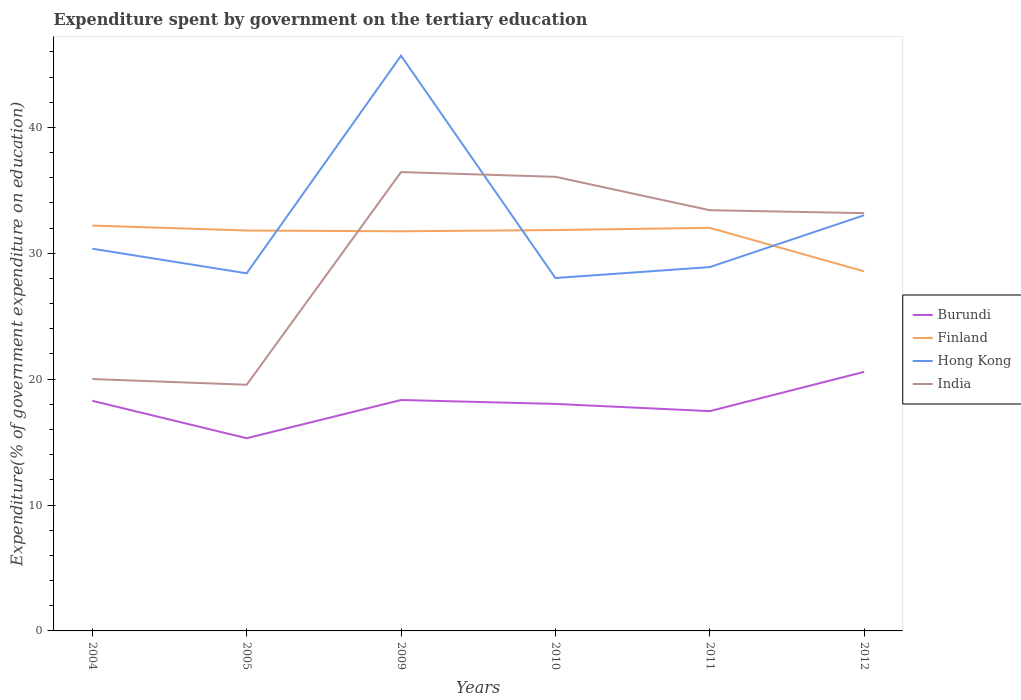Is the number of lines equal to the number of legend labels?
Provide a short and direct response. Yes. Across all years, what is the maximum expenditure spent by government on the tertiary education in Burundi?
Ensure brevity in your answer.  15.31. In which year was the expenditure spent by government on the tertiary education in Hong Kong maximum?
Make the answer very short. 2010. What is the total expenditure spent by government on the tertiary education in Finland in the graph?
Your answer should be very brief. 0.45. What is the difference between the highest and the second highest expenditure spent by government on the tertiary education in Burundi?
Offer a terse response. 5.27. Is the expenditure spent by government on the tertiary education in India strictly greater than the expenditure spent by government on the tertiary education in Finland over the years?
Provide a succinct answer. No. Are the values on the major ticks of Y-axis written in scientific E-notation?
Provide a succinct answer. No. Does the graph contain any zero values?
Keep it short and to the point. No. What is the title of the graph?
Give a very brief answer. Expenditure spent by government on the tertiary education. Does "Liechtenstein" appear as one of the legend labels in the graph?
Offer a terse response. No. What is the label or title of the X-axis?
Your response must be concise. Years. What is the label or title of the Y-axis?
Ensure brevity in your answer.  Expenditure(% of government expenditure on education). What is the Expenditure(% of government expenditure on education) in Burundi in 2004?
Offer a very short reply. 18.28. What is the Expenditure(% of government expenditure on education) of Finland in 2004?
Your response must be concise. 32.2. What is the Expenditure(% of government expenditure on education) in Hong Kong in 2004?
Ensure brevity in your answer.  30.36. What is the Expenditure(% of government expenditure on education) in India in 2004?
Your answer should be compact. 20.01. What is the Expenditure(% of government expenditure on education) of Burundi in 2005?
Provide a short and direct response. 15.31. What is the Expenditure(% of government expenditure on education) of Finland in 2005?
Offer a terse response. 31.81. What is the Expenditure(% of government expenditure on education) in Hong Kong in 2005?
Provide a short and direct response. 28.41. What is the Expenditure(% of government expenditure on education) of India in 2005?
Offer a very short reply. 19.55. What is the Expenditure(% of government expenditure on education) in Burundi in 2009?
Provide a short and direct response. 18.35. What is the Expenditure(% of government expenditure on education) in Finland in 2009?
Your answer should be very brief. 31.75. What is the Expenditure(% of government expenditure on education) of Hong Kong in 2009?
Keep it short and to the point. 45.7. What is the Expenditure(% of government expenditure on education) in India in 2009?
Give a very brief answer. 36.45. What is the Expenditure(% of government expenditure on education) of Burundi in 2010?
Make the answer very short. 18.03. What is the Expenditure(% of government expenditure on education) in Finland in 2010?
Give a very brief answer. 31.85. What is the Expenditure(% of government expenditure on education) of Hong Kong in 2010?
Keep it short and to the point. 28.04. What is the Expenditure(% of government expenditure on education) of India in 2010?
Your response must be concise. 36.08. What is the Expenditure(% of government expenditure on education) in Burundi in 2011?
Your answer should be very brief. 17.46. What is the Expenditure(% of government expenditure on education) in Finland in 2011?
Provide a short and direct response. 32.02. What is the Expenditure(% of government expenditure on education) in Hong Kong in 2011?
Give a very brief answer. 28.9. What is the Expenditure(% of government expenditure on education) of India in 2011?
Your answer should be very brief. 33.42. What is the Expenditure(% of government expenditure on education) of Burundi in 2012?
Provide a succinct answer. 20.58. What is the Expenditure(% of government expenditure on education) in Finland in 2012?
Your answer should be compact. 28.56. What is the Expenditure(% of government expenditure on education) of Hong Kong in 2012?
Your response must be concise. 33.02. What is the Expenditure(% of government expenditure on education) of India in 2012?
Offer a very short reply. 33.19. Across all years, what is the maximum Expenditure(% of government expenditure on education) in Burundi?
Your answer should be compact. 20.58. Across all years, what is the maximum Expenditure(% of government expenditure on education) of Finland?
Make the answer very short. 32.2. Across all years, what is the maximum Expenditure(% of government expenditure on education) in Hong Kong?
Provide a short and direct response. 45.7. Across all years, what is the maximum Expenditure(% of government expenditure on education) of India?
Keep it short and to the point. 36.45. Across all years, what is the minimum Expenditure(% of government expenditure on education) in Burundi?
Your answer should be very brief. 15.31. Across all years, what is the minimum Expenditure(% of government expenditure on education) in Finland?
Offer a very short reply. 28.56. Across all years, what is the minimum Expenditure(% of government expenditure on education) of Hong Kong?
Offer a very short reply. 28.04. Across all years, what is the minimum Expenditure(% of government expenditure on education) in India?
Offer a terse response. 19.55. What is the total Expenditure(% of government expenditure on education) in Burundi in the graph?
Offer a terse response. 108.01. What is the total Expenditure(% of government expenditure on education) of Finland in the graph?
Offer a terse response. 188.2. What is the total Expenditure(% of government expenditure on education) of Hong Kong in the graph?
Your answer should be very brief. 194.43. What is the total Expenditure(% of government expenditure on education) of India in the graph?
Your answer should be very brief. 178.71. What is the difference between the Expenditure(% of government expenditure on education) in Burundi in 2004 and that in 2005?
Provide a short and direct response. 2.98. What is the difference between the Expenditure(% of government expenditure on education) of Finland in 2004 and that in 2005?
Offer a terse response. 0.39. What is the difference between the Expenditure(% of government expenditure on education) in Hong Kong in 2004 and that in 2005?
Your response must be concise. 1.95. What is the difference between the Expenditure(% of government expenditure on education) in India in 2004 and that in 2005?
Your answer should be compact. 0.46. What is the difference between the Expenditure(% of government expenditure on education) of Burundi in 2004 and that in 2009?
Provide a succinct answer. -0.06. What is the difference between the Expenditure(% of government expenditure on education) of Finland in 2004 and that in 2009?
Keep it short and to the point. 0.45. What is the difference between the Expenditure(% of government expenditure on education) of Hong Kong in 2004 and that in 2009?
Offer a very short reply. -15.33. What is the difference between the Expenditure(% of government expenditure on education) in India in 2004 and that in 2009?
Make the answer very short. -16.44. What is the difference between the Expenditure(% of government expenditure on education) of Burundi in 2004 and that in 2010?
Provide a short and direct response. 0.25. What is the difference between the Expenditure(% of government expenditure on education) in Finland in 2004 and that in 2010?
Provide a succinct answer. 0.35. What is the difference between the Expenditure(% of government expenditure on education) of Hong Kong in 2004 and that in 2010?
Make the answer very short. 2.33. What is the difference between the Expenditure(% of government expenditure on education) of India in 2004 and that in 2010?
Your answer should be very brief. -16.06. What is the difference between the Expenditure(% of government expenditure on education) of Burundi in 2004 and that in 2011?
Ensure brevity in your answer.  0.82. What is the difference between the Expenditure(% of government expenditure on education) of Finland in 2004 and that in 2011?
Give a very brief answer. 0.18. What is the difference between the Expenditure(% of government expenditure on education) in Hong Kong in 2004 and that in 2011?
Provide a short and direct response. 1.46. What is the difference between the Expenditure(% of government expenditure on education) of India in 2004 and that in 2011?
Provide a short and direct response. -13.41. What is the difference between the Expenditure(% of government expenditure on education) in Burundi in 2004 and that in 2012?
Provide a succinct answer. -2.3. What is the difference between the Expenditure(% of government expenditure on education) in Finland in 2004 and that in 2012?
Give a very brief answer. 3.64. What is the difference between the Expenditure(% of government expenditure on education) in Hong Kong in 2004 and that in 2012?
Keep it short and to the point. -2.66. What is the difference between the Expenditure(% of government expenditure on education) of India in 2004 and that in 2012?
Ensure brevity in your answer.  -13.18. What is the difference between the Expenditure(% of government expenditure on education) in Burundi in 2005 and that in 2009?
Ensure brevity in your answer.  -3.04. What is the difference between the Expenditure(% of government expenditure on education) of Finland in 2005 and that in 2009?
Keep it short and to the point. 0.06. What is the difference between the Expenditure(% of government expenditure on education) of Hong Kong in 2005 and that in 2009?
Give a very brief answer. -17.29. What is the difference between the Expenditure(% of government expenditure on education) of India in 2005 and that in 2009?
Ensure brevity in your answer.  -16.9. What is the difference between the Expenditure(% of government expenditure on education) in Burundi in 2005 and that in 2010?
Ensure brevity in your answer.  -2.73. What is the difference between the Expenditure(% of government expenditure on education) of Finland in 2005 and that in 2010?
Offer a terse response. -0.04. What is the difference between the Expenditure(% of government expenditure on education) in Hong Kong in 2005 and that in 2010?
Provide a short and direct response. 0.37. What is the difference between the Expenditure(% of government expenditure on education) of India in 2005 and that in 2010?
Make the answer very short. -16.52. What is the difference between the Expenditure(% of government expenditure on education) of Burundi in 2005 and that in 2011?
Offer a terse response. -2.15. What is the difference between the Expenditure(% of government expenditure on education) in Finland in 2005 and that in 2011?
Give a very brief answer. -0.21. What is the difference between the Expenditure(% of government expenditure on education) of Hong Kong in 2005 and that in 2011?
Ensure brevity in your answer.  -0.49. What is the difference between the Expenditure(% of government expenditure on education) of India in 2005 and that in 2011?
Offer a very short reply. -13.87. What is the difference between the Expenditure(% of government expenditure on education) of Burundi in 2005 and that in 2012?
Ensure brevity in your answer.  -5.27. What is the difference between the Expenditure(% of government expenditure on education) of Finland in 2005 and that in 2012?
Provide a succinct answer. 3.25. What is the difference between the Expenditure(% of government expenditure on education) of Hong Kong in 2005 and that in 2012?
Ensure brevity in your answer.  -4.61. What is the difference between the Expenditure(% of government expenditure on education) in India in 2005 and that in 2012?
Provide a succinct answer. -13.63. What is the difference between the Expenditure(% of government expenditure on education) in Burundi in 2009 and that in 2010?
Your answer should be compact. 0.31. What is the difference between the Expenditure(% of government expenditure on education) of Finland in 2009 and that in 2010?
Your answer should be compact. -0.1. What is the difference between the Expenditure(% of government expenditure on education) of Hong Kong in 2009 and that in 2010?
Your response must be concise. 17.66. What is the difference between the Expenditure(% of government expenditure on education) of India in 2009 and that in 2010?
Your response must be concise. 0.37. What is the difference between the Expenditure(% of government expenditure on education) of Burundi in 2009 and that in 2011?
Give a very brief answer. 0.89. What is the difference between the Expenditure(% of government expenditure on education) of Finland in 2009 and that in 2011?
Offer a terse response. -0.27. What is the difference between the Expenditure(% of government expenditure on education) in Hong Kong in 2009 and that in 2011?
Offer a very short reply. 16.79. What is the difference between the Expenditure(% of government expenditure on education) in India in 2009 and that in 2011?
Make the answer very short. 3.03. What is the difference between the Expenditure(% of government expenditure on education) of Burundi in 2009 and that in 2012?
Your response must be concise. -2.23. What is the difference between the Expenditure(% of government expenditure on education) of Finland in 2009 and that in 2012?
Offer a terse response. 3.18. What is the difference between the Expenditure(% of government expenditure on education) in Hong Kong in 2009 and that in 2012?
Give a very brief answer. 12.67. What is the difference between the Expenditure(% of government expenditure on education) of India in 2009 and that in 2012?
Give a very brief answer. 3.26. What is the difference between the Expenditure(% of government expenditure on education) in Burundi in 2010 and that in 2011?
Provide a short and direct response. 0.57. What is the difference between the Expenditure(% of government expenditure on education) of Finland in 2010 and that in 2011?
Keep it short and to the point. -0.18. What is the difference between the Expenditure(% of government expenditure on education) in Hong Kong in 2010 and that in 2011?
Give a very brief answer. -0.87. What is the difference between the Expenditure(% of government expenditure on education) in India in 2010 and that in 2011?
Provide a short and direct response. 2.65. What is the difference between the Expenditure(% of government expenditure on education) in Burundi in 2010 and that in 2012?
Your answer should be compact. -2.55. What is the difference between the Expenditure(% of government expenditure on education) of Finland in 2010 and that in 2012?
Ensure brevity in your answer.  3.28. What is the difference between the Expenditure(% of government expenditure on education) in Hong Kong in 2010 and that in 2012?
Your answer should be very brief. -4.99. What is the difference between the Expenditure(% of government expenditure on education) of India in 2010 and that in 2012?
Offer a very short reply. 2.89. What is the difference between the Expenditure(% of government expenditure on education) in Burundi in 2011 and that in 2012?
Your answer should be very brief. -3.12. What is the difference between the Expenditure(% of government expenditure on education) in Finland in 2011 and that in 2012?
Offer a terse response. 3.46. What is the difference between the Expenditure(% of government expenditure on education) in Hong Kong in 2011 and that in 2012?
Make the answer very short. -4.12. What is the difference between the Expenditure(% of government expenditure on education) of India in 2011 and that in 2012?
Your response must be concise. 0.23. What is the difference between the Expenditure(% of government expenditure on education) in Burundi in 2004 and the Expenditure(% of government expenditure on education) in Finland in 2005?
Your response must be concise. -13.53. What is the difference between the Expenditure(% of government expenditure on education) of Burundi in 2004 and the Expenditure(% of government expenditure on education) of Hong Kong in 2005?
Your answer should be compact. -10.13. What is the difference between the Expenditure(% of government expenditure on education) of Burundi in 2004 and the Expenditure(% of government expenditure on education) of India in 2005?
Your response must be concise. -1.27. What is the difference between the Expenditure(% of government expenditure on education) in Finland in 2004 and the Expenditure(% of government expenditure on education) in Hong Kong in 2005?
Offer a very short reply. 3.79. What is the difference between the Expenditure(% of government expenditure on education) in Finland in 2004 and the Expenditure(% of government expenditure on education) in India in 2005?
Your answer should be compact. 12.65. What is the difference between the Expenditure(% of government expenditure on education) in Hong Kong in 2004 and the Expenditure(% of government expenditure on education) in India in 2005?
Ensure brevity in your answer.  10.81. What is the difference between the Expenditure(% of government expenditure on education) in Burundi in 2004 and the Expenditure(% of government expenditure on education) in Finland in 2009?
Provide a short and direct response. -13.47. What is the difference between the Expenditure(% of government expenditure on education) in Burundi in 2004 and the Expenditure(% of government expenditure on education) in Hong Kong in 2009?
Your response must be concise. -27.41. What is the difference between the Expenditure(% of government expenditure on education) in Burundi in 2004 and the Expenditure(% of government expenditure on education) in India in 2009?
Your answer should be compact. -18.17. What is the difference between the Expenditure(% of government expenditure on education) in Finland in 2004 and the Expenditure(% of government expenditure on education) in Hong Kong in 2009?
Keep it short and to the point. -13.5. What is the difference between the Expenditure(% of government expenditure on education) of Finland in 2004 and the Expenditure(% of government expenditure on education) of India in 2009?
Provide a succinct answer. -4.25. What is the difference between the Expenditure(% of government expenditure on education) in Hong Kong in 2004 and the Expenditure(% of government expenditure on education) in India in 2009?
Offer a terse response. -6.09. What is the difference between the Expenditure(% of government expenditure on education) in Burundi in 2004 and the Expenditure(% of government expenditure on education) in Finland in 2010?
Give a very brief answer. -13.56. What is the difference between the Expenditure(% of government expenditure on education) of Burundi in 2004 and the Expenditure(% of government expenditure on education) of Hong Kong in 2010?
Ensure brevity in your answer.  -9.75. What is the difference between the Expenditure(% of government expenditure on education) of Burundi in 2004 and the Expenditure(% of government expenditure on education) of India in 2010?
Provide a succinct answer. -17.79. What is the difference between the Expenditure(% of government expenditure on education) in Finland in 2004 and the Expenditure(% of government expenditure on education) in Hong Kong in 2010?
Ensure brevity in your answer.  4.17. What is the difference between the Expenditure(% of government expenditure on education) of Finland in 2004 and the Expenditure(% of government expenditure on education) of India in 2010?
Offer a terse response. -3.88. What is the difference between the Expenditure(% of government expenditure on education) of Hong Kong in 2004 and the Expenditure(% of government expenditure on education) of India in 2010?
Your response must be concise. -5.71. What is the difference between the Expenditure(% of government expenditure on education) in Burundi in 2004 and the Expenditure(% of government expenditure on education) in Finland in 2011?
Your response must be concise. -13.74. What is the difference between the Expenditure(% of government expenditure on education) in Burundi in 2004 and the Expenditure(% of government expenditure on education) in Hong Kong in 2011?
Offer a very short reply. -10.62. What is the difference between the Expenditure(% of government expenditure on education) in Burundi in 2004 and the Expenditure(% of government expenditure on education) in India in 2011?
Ensure brevity in your answer.  -15.14. What is the difference between the Expenditure(% of government expenditure on education) in Finland in 2004 and the Expenditure(% of government expenditure on education) in Hong Kong in 2011?
Your answer should be very brief. 3.3. What is the difference between the Expenditure(% of government expenditure on education) in Finland in 2004 and the Expenditure(% of government expenditure on education) in India in 2011?
Make the answer very short. -1.22. What is the difference between the Expenditure(% of government expenditure on education) of Hong Kong in 2004 and the Expenditure(% of government expenditure on education) of India in 2011?
Provide a short and direct response. -3.06. What is the difference between the Expenditure(% of government expenditure on education) of Burundi in 2004 and the Expenditure(% of government expenditure on education) of Finland in 2012?
Offer a very short reply. -10.28. What is the difference between the Expenditure(% of government expenditure on education) in Burundi in 2004 and the Expenditure(% of government expenditure on education) in Hong Kong in 2012?
Your answer should be compact. -14.74. What is the difference between the Expenditure(% of government expenditure on education) in Burundi in 2004 and the Expenditure(% of government expenditure on education) in India in 2012?
Your answer should be very brief. -14.91. What is the difference between the Expenditure(% of government expenditure on education) of Finland in 2004 and the Expenditure(% of government expenditure on education) of Hong Kong in 2012?
Your answer should be compact. -0.82. What is the difference between the Expenditure(% of government expenditure on education) in Finland in 2004 and the Expenditure(% of government expenditure on education) in India in 2012?
Ensure brevity in your answer.  -0.99. What is the difference between the Expenditure(% of government expenditure on education) of Hong Kong in 2004 and the Expenditure(% of government expenditure on education) of India in 2012?
Offer a terse response. -2.83. What is the difference between the Expenditure(% of government expenditure on education) of Burundi in 2005 and the Expenditure(% of government expenditure on education) of Finland in 2009?
Offer a terse response. -16.44. What is the difference between the Expenditure(% of government expenditure on education) of Burundi in 2005 and the Expenditure(% of government expenditure on education) of Hong Kong in 2009?
Your response must be concise. -30.39. What is the difference between the Expenditure(% of government expenditure on education) of Burundi in 2005 and the Expenditure(% of government expenditure on education) of India in 2009?
Make the answer very short. -21.14. What is the difference between the Expenditure(% of government expenditure on education) of Finland in 2005 and the Expenditure(% of government expenditure on education) of Hong Kong in 2009?
Give a very brief answer. -13.89. What is the difference between the Expenditure(% of government expenditure on education) of Finland in 2005 and the Expenditure(% of government expenditure on education) of India in 2009?
Make the answer very short. -4.64. What is the difference between the Expenditure(% of government expenditure on education) in Hong Kong in 2005 and the Expenditure(% of government expenditure on education) in India in 2009?
Your answer should be compact. -8.04. What is the difference between the Expenditure(% of government expenditure on education) of Burundi in 2005 and the Expenditure(% of government expenditure on education) of Finland in 2010?
Your answer should be compact. -16.54. What is the difference between the Expenditure(% of government expenditure on education) of Burundi in 2005 and the Expenditure(% of government expenditure on education) of Hong Kong in 2010?
Your answer should be very brief. -12.73. What is the difference between the Expenditure(% of government expenditure on education) of Burundi in 2005 and the Expenditure(% of government expenditure on education) of India in 2010?
Provide a succinct answer. -20.77. What is the difference between the Expenditure(% of government expenditure on education) in Finland in 2005 and the Expenditure(% of government expenditure on education) in Hong Kong in 2010?
Provide a succinct answer. 3.77. What is the difference between the Expenditure(% of government expenditure on education) of Finland in 2005 and the Expenditure(% of government expenditure on education) of India in 2010?
Your response must be concise. -4.27. What is the difference between the Expenditure(% of government expenditure on education) of Hong Kong in 2005 and the Expenditure(% of government expenditure on education) of India in 2010?
Keep it short and to the point. -7.67. What is the difference between the Expenditure(% of government expenditure on education) in Burundi in 2005 and the Expenditure(% of government expenditure on education) in Finland in 2011?
Provide a short and direct response. -16.72. What is the difference between the Expenditure(% of government expenditure on education) in Burundi in 2005 and the Expenditure(% of government expenditure on education) in Hong Kong in 2011?
Give a very brief answer. -13.6. What is the difference between the Expenditure(% of government expenditure on education) in Burundi in 2005 and the Expenditure(% of government expenditure on education) in India in 2011?
Your answer should be very brief. -18.11. What is the difference between the Expenditure(% of government expenditure on education) of Finland in 2005 and the Expenditure(% of government expenditure on education) of Hong Kong in 2011?
Ensure brevity in your answer.  2.91. What is the difference between the Expenditure(% of government expenditure on education) of Finland in 2005 and the Expenditure(% of government expenditure on education) of India in 2011?
Give a very brief answer. -1.61. What is the difference between the Expenditure(% of government expenditure on education) of Hong Kong in 2005 and the Expenditure(% of government expenditure on education) of India in 2011?
Give a very brief answer. -5.01. What is the difference between the Expenditure(% of government expenditure on education) of Burundi in 2005 and the Expenditure(% of government expenditure on education) of Finland in 2012?
Provide a short and direct response. -13.26. What is the difference between the Expenditure(% of government expenditure on education) in Burundi in 2005 and the Expenditure(% of government expenditure on education) in Hong Kong in 2012?
Make the answer very short. -17.71. What is the difference between the Expenditure(% of government expenditure on education) of Burundi in 2005 and the Expenditure(% of government expenditure on education) of India in 2012?
Ensure brevity in your answer.  -17.88. What is the difference between the Expenditure(% of government expenditure on education) in Finland in 2005 and the Expenditure(% of government expenditure on education) in Hong Kong in 2012?
Make the answer very short. -1.21. What is the difference between the Expenditure(% of government expenditure on education) of Finland in 2005 and the Expenditure(% of government expenditure on education) of India in 2012?
Provide a short and direct response. -1.38. What is the difference between the Expenditure(% of government expenditure on education) of Hong Kong in 2005 and the Expenditure(% of government expenditure on education) of India in 2012?
Give a very brief answer. -4.78. What is the difference between the Expenditure(% of government expenditure on education) of Burundi in 2009 and the Expenditure(% of government expenditure on education) of Finland in 2010?
Offer a very short reply. -13.5. What is the difference between the Expenditure(% of government expenditure on education) in Burundi in 2009 and the Expenditure(% of government expenditure on education) in Hong Kong in 2010?
Offer a very short reply. -9.69. What is the difference between the Expenditure(% of government expenditure on education) of Burundi in 2009 and the Expenditure(% of government expenditure on education) of India in 2010?
Provide a succinct answer. -17.73. What is the difference between the Expenditure(% of government expenditure on education) of Finland in 2009 and the Expenditure(% of government expenditure on education) of Hong Kong in 2010?
Provide a short and direct response. 3.71. What is the difference between the Expenditure(% of government expenditure on education) in Finland in 2009 and the Expenditure(% of government expenditure on education) in India in 2010?
Keep it short and to the point. -4.33. What is the difference between the Expenditure(% of government expenditure on education) of Hong Kong in 2009 and the Expenditure(% of government expenditure on education) of India in 2010?
Give a very brief answer. 9.62. What is the difference between the Expenditure(% of government expenditure on education) of Burundi in 2009 and the Expenditure(% of government expenditure on education) of Finland in 2011?
Keep it short and to the point. -13.68. What is the difference between the Expenditure(% of government expenditure on education) of Burundi in 2009 and the Expenditure(% of government expenditure on education) of Hong Kong in 2011?
Provide a short and direct response. -10.56. What is the difference between the Expenditure(% of government expenditure on education) of Burundi in 2009 and the Expenditure(% of government expenditure on education) of India in 2011?
Make the answer very short. -15.08. What is the difference between the Expenditure(% of government expenditure on education) of Finland in 2009 and the Expenditure(% of government expenditure on education) of Hong Kong in 2011?
Make the answer very short. 2.85. What is the difference between the Expenditure(% of government expenditure on education) of Finland in 2009 and the Expenditure(% of government expenditure on education) of India in 2011?
Keep it short and to the point. -1.67. What is the difference between the Expenditure(% of government expenditure on education) of Hong Kong in 2009 and the Expenditure(% of government expenditure on education) of India in 2011?
Offer a very short reply. 12.27. What is the difference between the Expenditure(% of government expenditure on education) of Burundi in 2009 and the Expenditure(% of government expenditure on education) of Finland in 2012?
Your answer should be very brief. -10.22. What is the difference between the Expenditure(% of government expenditure on education) in Burundi in 2009 and the Expenditure(% of government expenditure on education) in Hong Kong in 2012?
Offer a terse response. -14.68. What is the difference between the Expenditure(% of government expenditure on education) in Burundi in 2009 and the Expenditure(% of government expenditure on education) in India in 2012?
Your answer should be compact. -14.84. What is the difference between the Expenditure(% of government expenditure on education) in Finland in 2009 and the Expenditure(% of government expenditure on education) in Hong Kong in 2012?
Give a very brief answer. -1.27. What is the difference between the Expenditure(% of government expenditure on education) in Finland in 2009 and the Expenditure(% of government expenditure on education) in India in 2012?
Your response must be concise. -1.44. What is the difference between the Expenditure(% of government expenditure on education) of Hong Kong in 2009 and the Expenditure(% of government expenditure on education) of India in 2012?
Give a very brief answer. 12.51. What is the difference between the Expenditure(% of government expenditure on education) in Burundi in 2010 and the Expenditure(% of government expenditure on education) in Finland in 2011?
Ensure brevity in your answer.  -13.99. What is the difference between the Expenditure(% of government expenditure on education) of Burundi in 2010 and the Expenditure(% of government expenditure on education) of Hong Kong in 2011?
Your response must be concise. -10.87. What is the difference between the Expenditure(% of government expenditure on education) in Burundi in 2010 and the Expenditure(% of government expenditure on education) in India in 2011?
Your response must be concise. -15.39. What is the difference between the Expenditure(% of government expenditure on education) of Finland in 2010 and the Expenditure(% of government expenditure on education) of Hong Kong in 2011?
Give a very brief answer. 2.94. What is the difference between the Expenditure(% of government expenditure on education) in Finland in 2010 and the Expenditure(% of government expenditure on education) in India in 2011?
Give a very brief answer. -1.58. What is the difference between the Expenditure(% of government expenditure on education) in Hong Kong in 2010 and the Expenditure(% of government expenditure on education) in India in 2011?
Your answer should be very brief. -5.39. What is the difference between the Expenditure(% of government expenditure on education) in Burundi in 2010 and the Expenditure(% of government expenditure on education) in Finland in 2012?
Your response must be concise. -10.53. What is the difference between the Expenditure(% of government expenditure on education) of Burundi in 2010 and the Expenditure(% of government expenditure on education) of Hong Kong in 2012?
Provide a short and direct response. -14.99. What is the difference between the Expenditure(% of government expenditure on education) in Burundi in 2010 and the Expenditure(% of government expenditure on education) in India in 2012?
Provide a short and direct response. -15.16. What is the difference between the Expenditure(% of government expenditure on education) in Finland in 2010 and the Expenditure(% of government expenditure on education) in Hong Kong in 2012?
Your response must be concise. -1.18. What is the difference between the Expenditure(% of government expenditure on education) of Finland in 2010 and the Expenditure(% of government expenditure on education) of India in 2012?
Provide a succinct answer. -1.34. What is the difference between the Expenditure(% of government expenditure on education) of Hong Kong in 2010 and the Expenditure(% of government expenditure on education) of India in 2012?
Your response must be concise. -5.15. What is the difference between the Expenditure(% of government expenditure on education) of Burundi in 2011 and the Expenditure(% of government expenditure on education) of Finland in 2012?
Provide a short and direct response. -11.1. What is the difference between the Expenditure(% of government expenditure on education) of Burundi in 2011 and the Expenditure(% of government expenditure on education) of Hong Kong in 2012?
Give a very brief answer. -15.56. What is the difference between the Expenditure(% of government expenditure on education) of Burundi in 2011 and the Expenditure(% of government expenditure on education) of India in 2012?
Offer a very short reply. -15.73. What is the difference between the Expenditure(% of government expenditure on education) in Finland in 2011 and the Expenditure(% of government expenditure on education) in Hong Kong in 2012?
Keep it short and to the point. -1. What is the difference between the Expenditure(% of government expenditure on education) in Finland in 2011 and the Expenditure(% of government expenditure on education) in India in 2012?
Offer a very short reply. -1.17. What is the difference between the Expenditure(% of government expenditure on education) of Hong Kong in 2011 and the Expenditure(% of government expenditure on education) of India in 2012?
Ensure brevity in your answer.  -4.29. What is the average Expenditure(% of government expenditure on education) of Burundi per year?
Your answer should be compact. 18. What is the average Expenditure(% of government expenditure on education) in Finland per year?
Your answer should be very brief. 31.37. What is the average Expenditure(% of government expenditure on education) in Hong Kong per year?
Ensure brevity in your answer.  32.41. What is the average Expenditure(% of government expenditure on education) in India per year?
Keep it short and to the point. 29.78. In the year 2004, what is the difference between the Expenditure(% of government expenditure on education) of Burundi and Expenditure(% of government expenditure on education) of Finland?
Your response must be concise. -13.92. In the year 2004, what is the difference between the Expenditure(% of government expenditure on education) in Burundi and Expenditure(% of government expenditure on education) in Hong Kong?
Provide a succinct answer. -12.08. In the year 2004, what is the difference between the Expenditure(% of government expenditure on education) in Burundi and Expenditure(% of government expenditure on education) in India?
Offer a terse response. -1.73. In the year 2004, what is the difference between the Expenditure(% of government expenditure on education) of Finland and Expenditure(% of government expenditure on education) of Hong Kong?
Your response must be concise. 1.84. In the year 2004, what is the difference between the Expenditure(% of government expenditure on education) of Finland and Expenditure(% of government expenditure on education) of India?
Ensure brevity in your answer.  12.19. In the year 2004, what is the difference between the Expenditure(% of government expenditure on education) in Hong Kong and Expenditure(% of government expenditure on education) in India?
Provide a short and direct response. 10.35. In the year 2005, what is the difference between the Expenditure(% of government expenditure on education) of Burundi and Expenditure(% of government expenditure on education) of Finland?
Provide a succinct answer. -16.5. In the year 2005, what is the difference between the Expenditure(% of government expenditure on education) of Burundi and Expenditure(% of government expenditure on education) of Hong Kong?
Offer a terse response. -13.1. In the year 2005, what is the difference between the Expenditure(% of government expenditure on education) in Burundi and Expenditure(% of government expenditure on education) in India?
Provide a short and direct response. -4.25. In the year 2005, what is the difference between the Expenditure(% of government expenditure on education) in Finland and Expenditure(% of government expenditure on education) in Hong Kong?
Offer a terse response. 3.4. In the year 2005, what is the difference between the Expenditure(% of government expenditure on education) of Finland and Expenditure(% of government expenditure on education) of India?
Provide a succinct answer. 12.26. In the year 2005, what is the difference between the Expenditure(% of government expenditure on education) in Hong Kong and Expenditure(% of government expenditure on education) in India?
Offer a very short reply. 8.86. In the year 2009, what is the difference between the Expenditure(% of government expenditure on education) of Burundi and Expenditure(% of government expenditure on education) of Finland?
Offer a very short reply. -13.4. In the year 2009, what is the difference between the Expenditure(% of government expenditure on education) of Burundi and Expenditure(% of government expenditure on education) of Hong Kong?
Your answer should be very brief. -27.35. In the year 2009, what is the difference between the Expenditure(% of government expenditure on education) of Burundi and Expenditure(% of government expenditure on education) of India?
Provide a short and direct response. -18.11. In the year 2009, what is the difference between the Expenditure(% of government expenditure on education) in Finland and Expenditure(% of government expenditure on education) in Hong Kong?
Offer a terse response. -13.95. In the year 2009, what is the difference between the Expenditure(% of government expenditure on education) in Finland and Expenditure(% of government expenditure on education) in India?
Keep it short and to the point. -4.7. In the year 2009, what is the difference between the Expenditure(% of government expenditure on education) in Hong Kong and Expenditure(% of government expenditure on education) in India?
Your response must be concise. 9.25. In the year 2010, what is the difference between the Expenditure(% of government expenditure on education) of Burundi and Expenditure(% of government expenditure on education) of Finland?
Offer a very short reply. -13.81. In the year 2010, what is the difference between the Expenditure(% of government expenditure on education) in Burundi and Expenditure(% of government expenditure on education) in Hong Kong?
Give a very brief answer. -10. In the year 2010, what is the difference between the Expenditure(% of government expenditure on education) in Burundi and Expenditure(% of government expenditure on education) in India?
Your response must be concise. -18.04. In the year 2010, what is the difference between the Expenditure(% of government expenditure on education) of Finland and Expenditure(% of government expenditure on education) of Hong Kong?
Make the answer very short. 3.81. In the year 2010, what is the difference between the Expenditure(% of government expenditure on education) of Finland and Expenditure(% of government expenditure on education) of India?
Offer a terse response. -4.23. In the year 2010, what is the difference between the Expenditure(% of government expenditure on education) of Hong Kong and Expenditure(% of government expenditure on education) of India?
Offer a terse response. -8.04. In the year 2011, what is the difference between the Expenditure(% of government expenditure on education) in Burundi and Expenditure(% of government expenditure on education) in Finland?
Make the answer very short. -14.56. In the year 2011, what is the difference between the Expenditure(% of government expenditure on education) of Burundi and Expenditure(% of government expenditure on education) of Hong Kong?
Provide a short and direct response. -11.44. In the year 2011, what is the difference between the Expenditure(% of government expenditure on education) in Burundi and Expenditure(% of government expenditure on education) in India?
Ensure brevity in your answer.  -15.96. In the year 2011, what is the difference between the Expenditure(% of government expenditure on education) in Finland and Expenditure(% of government expenditure on education) in Hong Kong?
Provide a succinct answer. 3.12. In the year 2011, what is the difference between the Expenditure(% of government expenditure on education) in Finland and Expenditure(% of government expenditure on education) in India?
Offer a very short reply. -1.4. In the year 2011, what is the difference between the Expenditure(% of government expenditure on education) of Hong Kong and Expenditure(% of government expenditure on education) of India?
Keep it short and to the point. -4.52. In the year 2012, what is the difference between the Expenditure(% of government expenditure on education) in Burundi and Expenditure(% of government expenditure on education) in Finland?
Keep it short and to the point. -7.99. In the year 2012, what is the difference between the Expenditure(% of government expenditure on education) of Burundi and Expenditure(% of government expenditure on education) of Hong Kong?
Ensure brevity in your answer.  -12.44. In the year 2012, what is the difference between the Expenditure(% of government expenditure on education) in Burundi and Expenditure(% of government expenditure on education) in India?
Give a very brief answer. -12.61. In the year 2012, what is the difference between the Expenditure(% of government expenditure on education) of Finland and Expenditure(% of government expenditure on education) of Hong Kong?
Your answer should be compact. -4.46. In the year 2012, what is the difference between the Expenditure(% of government expenditure on education) of Finland and Expenditure(% of government expenditure on education) of India?
Give a very brief answer. -4.63. In the year 2012, what is the difference between the Expenditure(% of government expenditure on education) in Hong Kong and Expenditure(% of government expenditure on education) in India?
Provide a short and direct response. -0.17. What is the ratio of the Expenditure(% of government expenditure on education) of Burundi in 2004 to that in 2005?
Your answer should be very brief. 1.19. What is the ratio of the Expenditure(% of government expenditure on education) in Finland in 2004 to that in 2005?
Your response must be concise. 1.01. What is the ratio of the Expenditure(% of government expenditure on education) of Hong Kong in 2004 to that in 2005?
Your answer should be compact. 1.07. What is the ratio of the Expenditure(% of government expenditure on education) of India in 2004 to that in 2005?
Ensure brevity in your answer.  1.02. What is the ratio of the Expenditure(% of government expenditure on education) in Finland in 2004 to that in 2009?
Make the answer very short. 1.01. What is the ratio of the Expenditure(% of government expenditure on education) in Hong Kong in 2004 to that in 2009?
Ensure brevity in your answer.  0.66. What is the ratio of the Expenditure(% of government expenditure on education) in India in 2004 to that in 2009?
Your answer should be very brief. 0.55. What is the ratio of the Expenditure(% of government expenditure on education) of Burundi in 2004 to that in 2010?
Make the answer very short. 1.01. What is the ratio of the Expenditure(% of government expenditure on education) in Finland in 2004 to that in 2010?
Provide a succinct answer. 1.01. What is the ratio of the Expenditure(% of government expenditure on education) of Hong Kong in 2004 to that in 2010?
Keep it short and to the point. 1.08. What is the ratio of the Expenditure(% of government expenditure on education) in India in 2004 to that in 2010?
Provide a succinct answer. 0.55. What is the ratio of the Expenditure(% of government expenditure on education) of Burundi in 2004 to that in 2011?
Give a very brief answer. 1.05. What is the ratio of the Expenditure(% of government expenditure on education) of Finland in 2004 to that in 2011?
Provide a succinct answer. 1.01. What is the ratio of the Expenditure(% of government expenditure on education) in Hong Kong in 2004 to that in 2011?
Your answer should be very brief. 1.05. What is the ratio of the Expenditure(% of government expenditure on education) of India in 2004 to that in 2011?
Make the answer very short. 0.6. What is the ratio of the Expenditure(% of government expenditure on education) of Burundi in 2004 to that in 2012?
Your answer should be very brief. 0.89. What is the ratio of the Expenditure(% of government expenditure on education) in Finland in 2004 to that in 2012?
Your response must be concise. 1.13. What is the ratio of the Expenditure(% of government expenditure on education) of Hong Kong in 2004 to that in 2012?
Your answer should be compact. 0.92. What is the ratio of the Expenditure(% of government expenditure on education) in India in 2004 to that in 2012?
Provide a succinct answer. 0.6. What is the ratio of the Expenditure(% of government expenditure on education) in Burundi in 2005 to that in 2009?
Provide a short and direct response. 0.83. What is the ratio of the Expenditure(% of government expenditure on education) of Hong Kong in 2005 to that in 2009?
Provide a succinct answer. 0.62. What is the ratio of the Expenditure(% of government expenditure on education) of India in 2005 to that in 2009?
Offer a terse response. 0.54. What is the ratio of the Expenditure(% of government expenditure on education) of Burundi in 2005 to that in 2010?
Ensure brevity in your answer.  0.85. What is the ratio of the Expenditure(% of government expenditure on education) of Hong Kong in 2005 to that in 2010?
Provide a short and direct response. 1.01. What is the ratio of the Expenditure(% of government expenditure on education) in India in 2005 to that in 2010?
Your answer should be very brief. 0.54. What is the ratio of the Expenditure(% of government expenditure on education) in Burundi in 2005 to that in 2011?
Offer a very short reply. 0.88. What is the ratio of the Expenditure(% of government expenditure on education) of Finland in 2005 to that in 2011?
Provide a succinct answer. 0.99. What is the ratio of the Expenditure(% of government expenditure on education) of Hong Kong in 2005 to that in 2011?
Offer a very short reply. 0.98. What is the ratio of the Expenditure(% of government expenditure on education) in India in 2005 to that in 2011?
Offer a terse response. 0.59. What is the ratio of the Expenditure(% of government expenditure on education) of Burundi in 2005 to that in 2012?
Keep it short and to the point. 0.74. What is the ratio of the Expenditure(% of government expenditure on education) in Finland in 2005 to that in 2012?
Your answer should be very brief. 1.11. What is the ratio of the Expenditure(% of government expenditure on education) in Hong Kong in 2005 to that in 2012?
Offer a very short reply. 0.86. What is the ratio of the Expenditure(% of government expenditure on education) of India in 2005 to that in 2012?
Ensure brevity in your answer.  0.59. What is the ratio of the Expenditure(% of government expenditure on education) of Burundi in 2009 to that in 2010?
Your response must be concise. 1.02. What is the ratio of the Expenditure(% of government expenditure on education) in Hong Kong in 2009 to that in 2010?
Make the answer very short. 1.63. What is the ratio of the Expenditure(% of government expenditure on education) in India in 2009 to that in 2010?
Offer a very short reply. 1.01. What is the ratio of the Expenditure(% of government expenditure on education) of Burundi in 2009 to that in 2011?
Offer a very short reply. 1.05. What is the ratio of the Expenditure(% of government expenditure on education) of Hong Kong in 2009 to that in 2011?
Provide a succinct answer. 1.58. What is the ratio of the Expenditure(% of government expenditure on education) of India in 2009 to that in 2011?
Offer a terse response. 1.09. What is the ratio of the Expenditure(% of government expenditure on education) of Burundi in 2009 to that in 2012?
Keep it short and to the point. 0.89. What is the ratio of the Expenditure(% of government expenditure on education) in Finland in 2009 to that in 2012?
Give a very brief answer. 1.11. What is the ratio of the Expenditure(% of government expenditure on education) of Hong Kong in 2009 to that in 2012?
Offer a very short reply. 1.38. What is the ratio of the Expenditure(% of government expenditure on education) in India in 2009 to that in 2012?
Your response must be concise. 1.1. What is the ratio of the Expenditure(% of government expenditure on education) of Burundi in 2010 to that in 2011?
Your response must be concise. 1.03. What is the ratio of the Expenditure(% of government expenditure on education) of Hong Kong in 2010 to that in 2011?
Provide a short and direct response. 0.97. What is the ratio of the Expenditure(% of government expenditure on education) in India in 2010 to that in 2011?
Your answer should be compact. 1.08. What is the ratio of the Expenditure(% of government expenditure on education) of Burundi in 2010 to that in 2012?
Your answer should be very brief. 0.88. What is the ratio of the Expenditure(% of government expenditure on education) of Finland in 2010 to that in 2012?
Ensure brevity in your answer.  1.11. What is the ratio of the Expenditure(% of government expenditure on education) of Hong Kong in 2010 to that in 2012?
Ensure brevity in your answer.  0.85. What is the ratio of the Expenditure(% of government expenditure on education) of India in 2010 to that in 2012?
Make the answer very short. 1.09. What is the ratio of the Expenditure(% of government expenditure on education) of Burundi in 2011 to that in 2012?
Offer a very short reply. 0.85. What is the ratio of the Expenditure(% of government expenditure on education) in Finland in 2011 to that in 2012?
Give a very brief answer. 1.12. What is the ratio of the Expenditure(% of government expenditure on education) in Hong Kong in 2011 to that in 2012?
Offer a terse response. 0.88. What is the difference between the highest and the second highest Expenditure(% of government expenditure on education) in Burundi?
Provide a succinct answer. 2.23. What is the difference between the highest and the second highest Expenditure(% of government expenditure on education) in Finland?
Give a very brief answer. 0.18. What is the difference between the highest and the second highest Expenditure(% of government expenditure on education) in Hong Kong?
Keep it short and to the point. 12.67. What is the difference between the highest and the second highest Expenditure(% of government expenditure on education) in India?
Your answer should be compact. 0.37. What is the difference between the highest and the lowest Expenditure(% of government expenditure on education) in Burundi?
Make the answer very short. 5.27. What is the difference between the highest and the lowest Expenditure(% of government expenditure on education) of Finland?
Offer a terse response. 3.64. What is the difference between the highest and the lowest Expenditure(% of government expenditure on education) in Hong Kong?
Give a very brief answer. 17.66. What is the difference between the highest and the lowest Expenditure(% of government expenditure on education) of India?
Your answer should be compact. 16.9. 